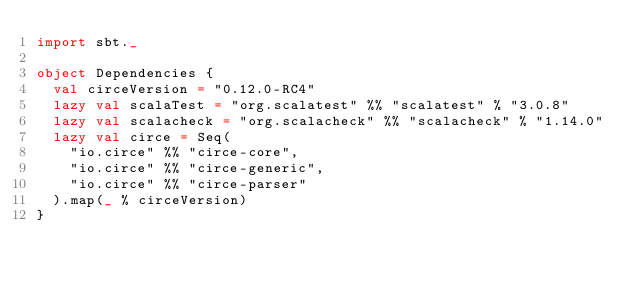<code> <loc_0><loc_0><loc_500><loc_500><_Scala_>import sbt._

object Dependencies {
  val circeVersion = "0.12.0-RC4"
  lazy val scalaTest = "org.scalatest" %% "scalatest" % "3.0.8"
  lazy val scalacheck = "org.scalacheck" %% "scalacheck" % "1.14.0"
  lazy val circe = Seq(
    "io.circe" %% "circe-core",
    "io.circe" %% "circe-generic",
    "io.circe" %% "circe-parser"
  ).map(_ % circeVersion)
}
</code> 